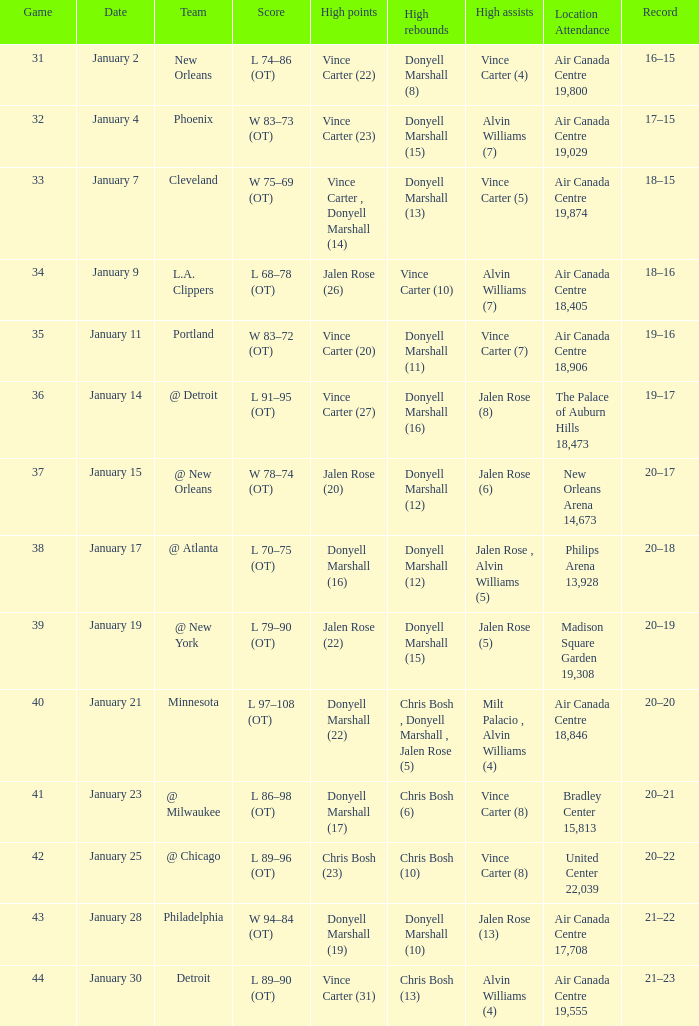What is the Location and Attendance with a Record of 21–22? Air Canada Centre 17,708. 